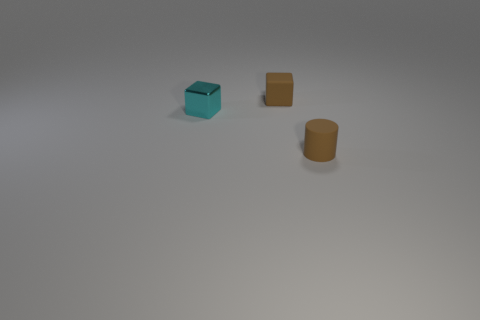What could be the function of these objects given their sizes and shapes? Based on their sizes and shapes, the cube with the cavity could serve as a container or a miniature model of a storage item. The rectangular cuboid might resemble a small stand or block used for building or display purposes. The cylindrical object could function as a pen holder or a simplistic model for a container with an open top for holding items. 